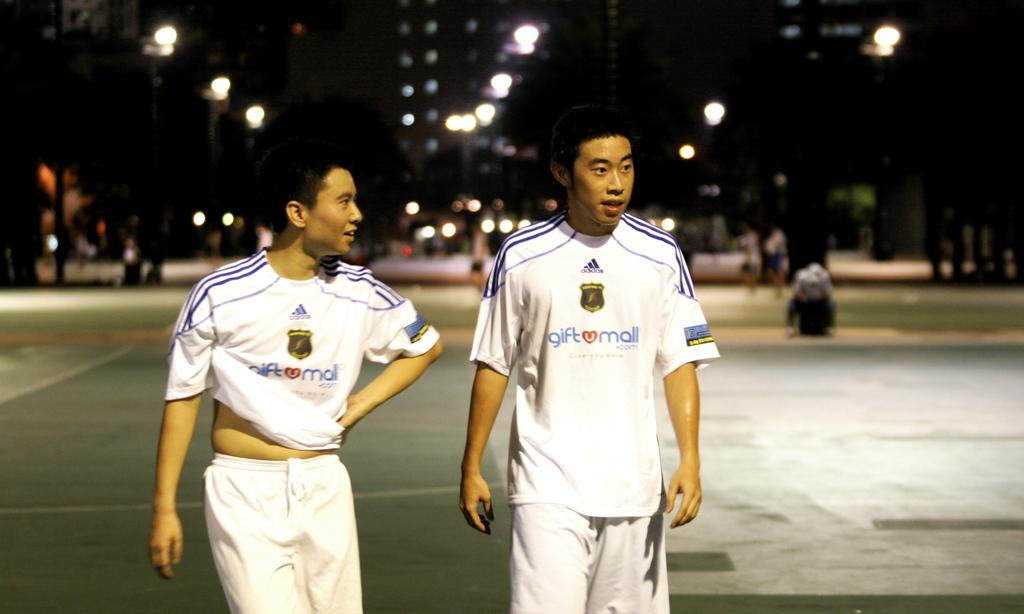<image>
Summarize the visual content of the image. Two men walking together at night in white uniforms that say giftumall.com on the front. 